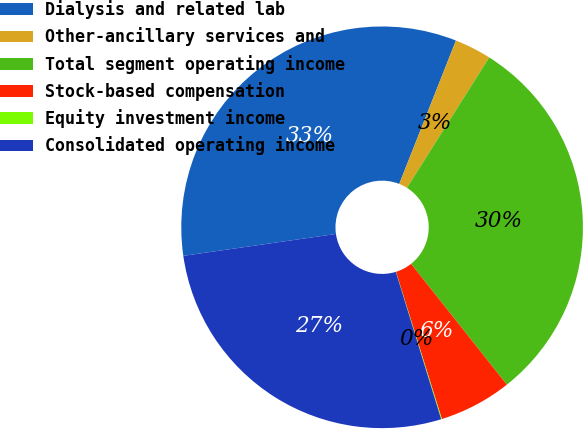Convert chart to OTSL. <chart><loc_0><loc_0><loc_500><loc_500><pie_chart><fcel>Dialysis and related lab<fcel>Other-ancillary services and<fcel>Total segment operating income<fcel>Stock-based compensation<fcel>Equity investment income<fcel>Consolidated operating income<nl><fcel>33.27%<fcel>2.96%<fcel>30.38%<fcel>5.86%<fcel>0.06%<fcel>27.48%<nl></chart> 